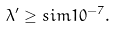<formula> <loc_0><loc_0><loc_500><loc_500>\lambda ^ { \prime } \geq s i m 1 0 ^ { - 7 } .</formula> 